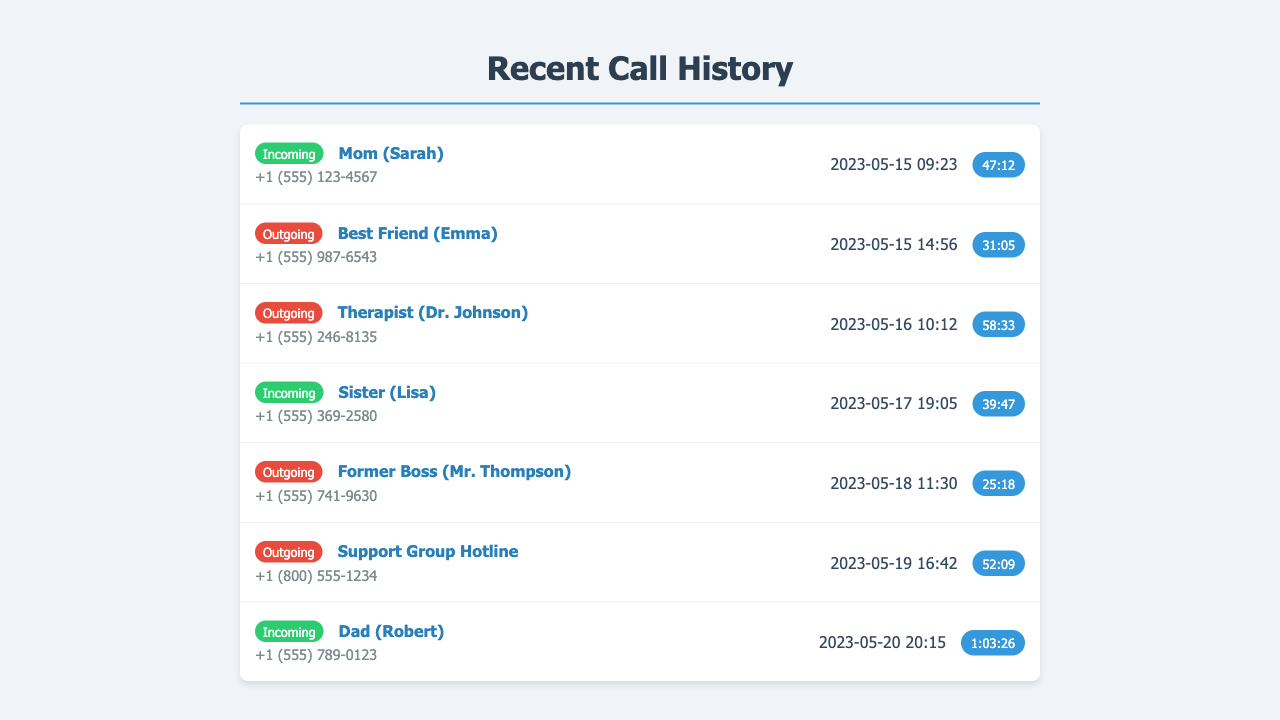What is the name of the first caller? The first caller in the document is mentioned as "Mom (Sarah)".
Answer: Mom (Sarah) How many calls did you make to close family members? The call history shows calls made to close family members such as Mom, Sister, and Dad, totaling four calls.
Answer: 4 What was the duration of the call with Dad? The duration of the call with Dad (Robert) is noted as "1:03:26".
Answer: 1:03:26 What type of call was made to the Therapist? The call made to the Therapist (Dr. Johnson) is categorized as an "Outgoing" call.
Answer: Outgoing Who was the last person you spoke to on the list? The last person mentioned in the list is "Dad (Robert)".
Answer: Dad (Robert) When did the last call occur? The last call took place on "2023-05-20".
Answer: 2023-05-20 What is the contact number for the Support Group Hotline? The Support Group Hotline's contact number is listed as "+1 (800) 555-1234".
Answer: +1 (800) 555-1234 How long was the call with your Sister? The duration of the call with Sister (Lisa) is "39:47".
Answer: 39:47 What was the date of the first outgoing call? The first outgoing call occurred on "2023-05-15".
Answer: 2023-05-15 What is the total number of incoming calls in the document? The total number of incoming calls, including those from Mom, Sister, and Dad, is four.
Answer: 4 